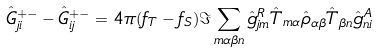<formula> <loc_0><loc_0><loc_500><loc_500>\hat { G } _ { j i } ^ { + - } - \hat { G } _ { i j } ^ { + - } = 4 \pi ( f _ { T } - f _ { S } ) \Im \sum _ { m \alpha \beta n } \hat { g } _ { j m } ^ { R } \hat { T } _ { m \alpha } \hat { \rho } _ { \alpha \beta } \hat { T } _ { \beta n } \hat { g } _ { n i } ^ { A }</formula> 